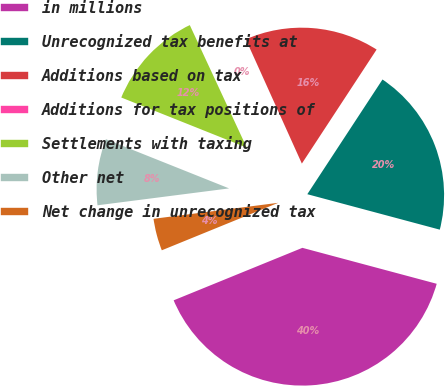Convert chart. <chart><loc_0><loc_0><loc_500><loc_500><pie_chart><fcel>in millions<fcel>Unrecognized tax benefits at<fcel>Additions based on tax<fcel>Additions for tax positions of<fcel>Settlements with taxing<fcel>Other net<fcel>Net change in unrecognized tax<nl><fcel>39.68%<fcel>19.93%<fcel>15.98%<fcel>0.18%<fcel>12.03%<fcel>8.08%<fcel>4.13%<nl></chart> 